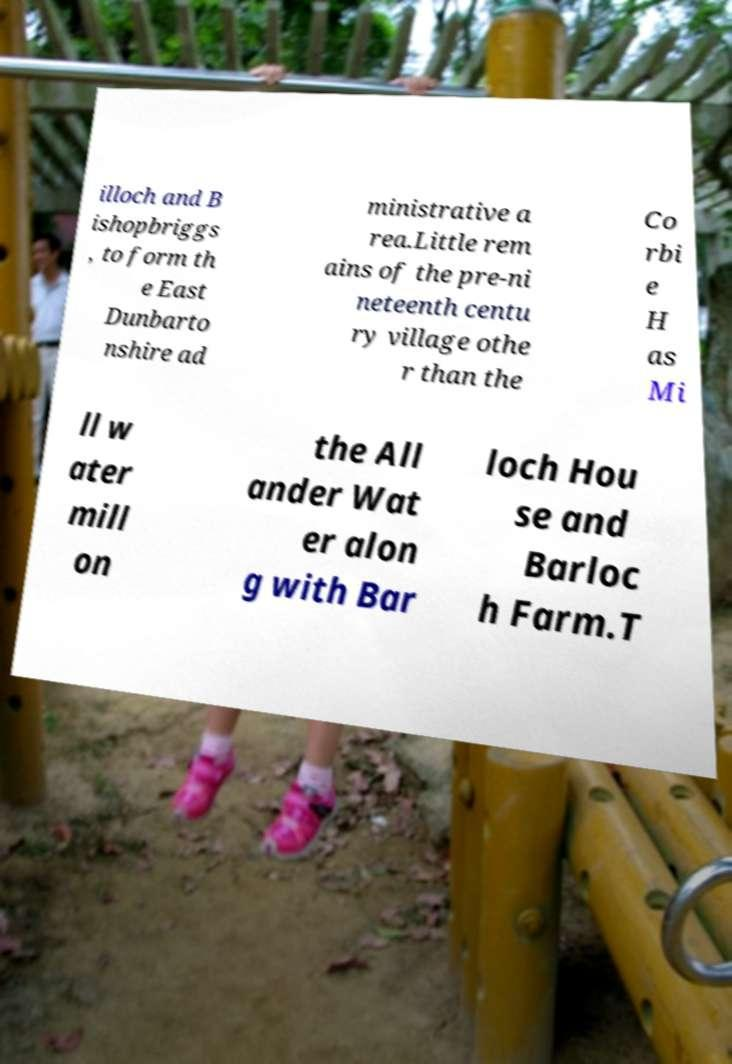Please read and relay the text visible in this image. What does it say? illoch and B ishopbriggs , to form th e East Dunbarto nshire ad ministrative a rea.Little rem ains of the pre-ni neteenth centu ry village othe r than the Co rbi e H as Mi ll w ater mill on the All ander Wat er alon g with Bar loch Hou se and Barloc h Farm.T 